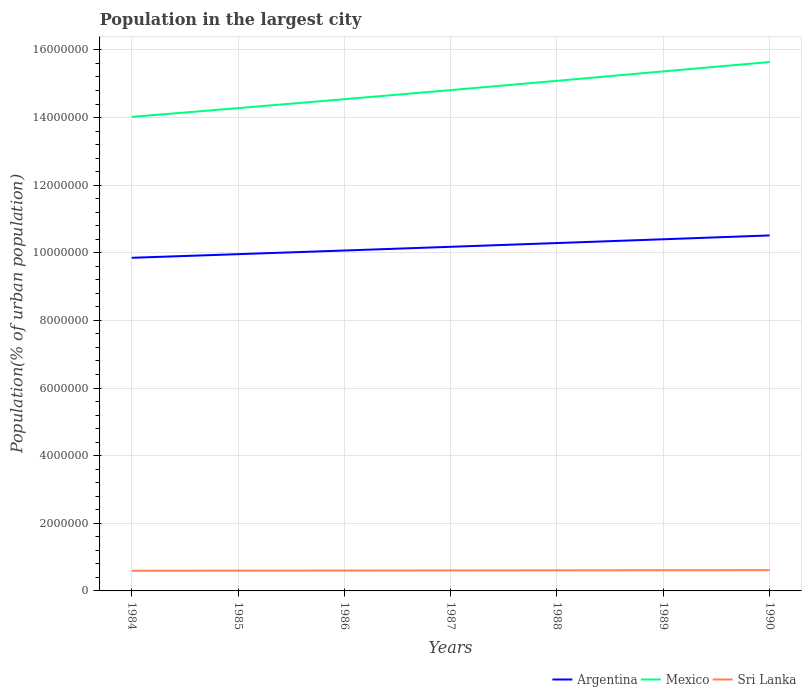Does the line corresponding to Sri Lanka intersect with the line corresponding to Mexico?
Offer a very short reply. No. Is the number of lines equal to the number of legend labels?
Make the answer very short. Yes. Across all years, what is the maximum population in the largest city in Argentina?
Your response must be concise. 9.85e+06. In which year was the population in the largest city in Mexico maximum?
Offer a very short reply. 1984. What is the total population in the largest city in Sri Lanka in the graph?
Keep it short and to the point. -1.15e+04. What is the difference between the highest and the second highest population in the largest city in Sri Lanka?
Keep it short and to the point. 1.72e+04. Does the graph contain grids?
Provide a short and direct response. Yes. Where does the legend appear in the graph?
Provide a short and direct response. Bottom right. How many legend labels are there?
Your answer should be very brief. 3. What is the title of the graph?
Make the answer very short. Population in the largest city. Does "Pakistan" appear as one of the legend labels in the graph?
Offer a terse response. No. What is the label or title of the Y-axis?
Make the answer very short. Population(% of urban population). What is the Population(% of urban population) of Argentina in 1984?
Your response must be concise. 9.85e+06. What is the Population(% of urban population) in Mexico in 1984?
Provide a succinct answer. 1.40e+07. What is the Population(% of urban population) in Sri Lanka in 1984?
Offer a terse response. 5.97e+05. What is the Population(% of urban population) in Argentina in 1985?
Keep it short and to the point. 9.96e+06. What is the Population(% of urban population) of Mexico in 1985?
Provide a short and direct response. 1.43e+07. What is the Population(% of urban population) in Sri Lanka in 1985?
Ensure brevity in your answer.  6.00e+05. What is the Population(% of urban population) in Argentina in 1986?
Your response must be concise. 1.01e+07. What is the Population(% of urban population) in Mexico in 1986?
Provide a short and direct response. 1.45e+07. What is the Population(% of urban population) in Sri Lanka in 1986?
Make the answer very short. 6.03e+05. What is the Population(% of urban population) of Argentina in 1987?
Provide a short and direct response. 1.02e+07. What is the Population(% of urban population) in Mexico in 1987?
Your answer should be compact. 1.48e+07. What is the Population(% of urban population) of Sri Lanka in 1987?
Provide a short and direct response. 6.05e+05. What is the Population(% of urban population) of Argentina in 1988?
Your answer should be compact. 1.03e+07. What is the Population(% of urban population) in Mexico in 1988?
Offer a terse response. 1.51e+07. What is the Population(% of urban population) of Sri Lanka in 1988?
Make the answer very short. 6.08e+05. What is the Population(% of urban population) of Argentina in 1989?
Make the answer very short. 1.04e+07. What is the Population(% of urban population) in Mexico in 1989?
Your response must be concise. 1.54e+07. What is the Population(% of urban population) in Sri Lanka in 1989?
Keep it short and to the point. 6.11e+05. What is the Population(% of urban population) of Argentina in 1990?
Your answer should be very brief. 1.05e+07. What is the Population(% of urban population) of Mexico in 1990?
Provide a short and direct response. 1.56e+07. What is the Population(% of urban population) of Sri Lanka in 1990?
Offer a terse response. 6.14e+05. Across all years, what is the maximum Population(% of urban population) in Argentina?
Ensure brevity in your answer.  1.05e+07. Across all years, what is the maximum Population(% of urban population) in Mexico?
Provide a succinct answer. 1.56e+07. Across all years, what is the maximum Population(% of urban population) in Sri Lanka?
Make the answer very short. 6.14e+05. Across all years, what is the minimum Population(% of urban population) in Argentina?
Give a very brief answer. 9.85e+06. Across all years, what is the minimum Population(% of urban population) of Mexico?
Your response must be concise. 1.40e+07. Across all years, what is the minimum Population(% of urban population) in Sri Lanka?
Your answer should be very brief. 5.97e+05. What is the total Population(% of urban population) of Argentina in the graph?
Give a very brief answer. 7.13e+07. What is the total Population(% of urban population) in Mexico in the graph?
Offer a very short reply. 1.04e+08. What is the total Population(% of urban population) of Sri Lanka in the graph?
Provide a succinct answer. 4.24e+06. What is the difference between the Population(% of urban population) in Argentina in 1984 and that in 1985?
Your answer should be compact. -1.07e+05. What is the difference between the Population(% of urban population) of Mexico in 1984 and that in 1985?
Ensure brevity in your answer.  -2.59e+05. What is the difference between the Population(% of urban population) of Sri Lanka in 1984 and that in 1985?
Make the answer very short. -2832. What is the difference between the Population(% of urban population) of Argentina in 1984 and that in 1986?
Provide a short and direct response. -2.16e+05. What is the difference between the Population(% of urban population) in Mexico in 1984 and that in 1986?
Your answer should be very brief. -5.23e+05. What is the difference between the Population(% of urban population) of Sri Lanka in 1984 and that in 1986?
Offer a very short reply. -5681. What is the difference between the Population(% of urban population) of Argentina in 1984 and that in 1987?
Provide a succinct answer. -3.25e+05. What is the difference between the Population(% of urban population) of Mexico in 1984 and that in 1987?
Offer a very short reply. -7.92e+05. What is the difference between the Population(% of urban population) of Sri Lanka in 1984 and that in 1987?
Offer a very short reply. -8544. What is the difference between the Population(% of urban population) in Argentina in 1984 and that in 1988?
Your answer should be compact. -4.36e+05. What is the difference between the Population(% of urban population) in Mexico in 1984 and that in 1988?
Make the answer very short. -1.07e+06. What is the difference between the Population(% of urban population) of Sri Lanka in 1984 and that in 1988?
Your answer should be very brief. -1.14e+04. What is the difference between the Population(% of urban population) in Argentina in 1984 and that in 1989?
Your answer should be compact. -5.48e+05. What is the difference between the Population(% of urban population) in Mexico in 1984 and that in 1989?
Your answer should be very brief. -1.35e+06. What is the difference between the Population(% of urban population) in Sri Lanka in 1984 and that in 1989?
Give a very brief answer. -1.43e+04. What is the difference between the Population(% of urban population) in Argentina in 1984 and that in 1990?
Offer a very short reply. -6.61e+05. What is the difference between the Population(% of urban population) of Mexico in 1984 and that in 1990?
Make the answer very short. -1.62e+06. What is the difference between the Population(% of urban population) of Sri Lanka in 1984 and that in 1990?
Provide a succinct answer. -1.72e+04. What is the difference between the Population(% of urban population) of Argentina in 1985 and that in 1986?
Your answer should be very brief. -1.08e+05. What is the difference between the Population(% of urban population) in Mexico in 1985 and that in 1986?
Make the answer very short. -2.64e+05. What is the difference between the Population(% of urban population) in Sri Lanka in 1985 and that in 1986?
Your answer should be very brief. -2849. What is the difference between the Population(% of urban population) in Argentina in 1985 and that in 1987?
Give a very brief answer. -2.18e+05. What is the difference between the Population(% of urban population) of Mexico in 1985 and that in 1987?
Keep it short and to the point. -5.33e+05. What is the difference between the Population(% of urban population) of Sri Lanka in 1985 and that in 1987?
Provide a short and direct response. -5712. What is the difference between the Population(% of urban population) of Argentina in 1985 and that in 1988?
Your response must be concise. -3.29e+05. What is the difference between the Population(% of urban population) of Mexico in 1985 and that in 1988?
Provide a succinct answer. -8.08e+05. What is the difference between the Population(% of urban population) in Sri Lanka in 1985 and that in 1988?
Give a very brief answer. -8592. What is the difference between the Population(% of urban population) of Argentina in 1985 and that in 1989?
Ensure brevity in your answer.  -4.41e+05. What is the difference between the Population(% of urban population) of Mexico in 1985 and that in 1989?
Make the answer very short. -1.09e+06. What is the difference between the Population(% of urban population) in Sri Lanka in 1985 and that in 1989?
Keep it short and to the point. -1.15e+04. What is the difference between the Population(% of urban population) in Argentina in 1985 and that in 1990?
Make the answer very short. -5.54e+05. What is the difference between the Population(% of urban population) in Mexico in 1985 and that in 1990?
Make the answer very short. -1.36e+06. What is the difference between the Population(% of urban population) of Sri Lanka in 1985 and that in 1990?
Give a very brief answer. -1.44e+04. What is the difference between the Population(% of urban population) in Argentina in 1986 and that in 1987?
Ensure brevity in your answer.  -1.10e+05. What is the difference between the Population(% of urban population) in Mexico in 1986 and that in 1987?
Provide a succinct answer. -2.69e+05. What is the difference between the Population(% of urban population) in Sri Lanka in 1986 and that in 1987?
Your response must be concise. -2863. What is the difference between the Population(% of urban population) in Argentina in 1986 and that in 1988?
Your answer should be compact. -2.21e+05. What is the difference between the Population(% of urban population) of Mexico in 1986 and that in 1988?
Ensure brevity in your answer.  -5.44e+05. What is the difference between the Population(% of urban population) of Sri Lanka in 1986 and that in 1988?
Offer a terse response. -5743. What is the difference between the Population(% of urban population) of Argentina in 1986 and that in 1989?
Your response must be concise. -3.32e+05. What is the difference between the Population(% of urban population) of Mexico in 1986 and that in 1989?
Keep it short and to the point. -8.22e+05. What is the difference between the Population(% of urban population) in Sri Lanka in 1986 and that in 1989?
Your response must be concise. -8629. What is the difference between the Population(% of urban population) in Argentina in 1986 and that in 1990?
Offer a terse response. -4.46e+05. What is the difference between the Population(% of urban population) of Mexico in 1986 and that in 1990?
Offer a very short reply. -1.10e+06. What is the difference between the Population(% of urban population) of Sri Lanka in 1986 and that in 1990?
Your response must be concise. -1.15e+04. What is the difference between the Population(% of urban population) in Argentina in 1987 and that in 1988?
Offer a very short reply. -1.11e+05. What is the difference between the Population(% of urban population) of Mexico in 1987 and that in 1988?
Provide a succinct answer. -2.74e+05. What is the difference between the Population(% of urban population) in Sri Lanka in 1987 and that in 1988?
Your answer should be compact. -2880. What is the difference between the Population(% of urban population) of Argentina in 1987 and that in 1989?
Your answer should be compact. -2.23e+05. What is the difference between the Population(% of urban population) of Mexico in 1987 and that in 1989?
Give a very brief answer. -5.53e+05. What is the difference between the Population(% of urban population) in Sri Lanka in 1987 and that in 1989?
Provide a short and direct response. -5766. What is the difference between the Population(% of urban population) in Argentina in 1987 and that in 1990?
Give a very brief answer. -3.36e+05. What is the difference between the Population(% of urban population) in Mexico in 1987 and that in 1990?
Provide a succinct answer. -8.31e+05. What is the difference between the Population(% of urban population) of Sri Lanka in 1987 and that in 1990?
Make the answer very short. -8669. What is the difference between the Population(% of urban population) of Argentina in 1988 and that in 1989?
Keep it short and to the point. -1.12e+05. What is the difference between the Population(% of urban population) in Mexico in 1988 and that in 1989?
Keep it short and to the point. -2.79e+05. What is the difference between the Population(% of urban population) of Sri Lanka in 1988 and that in 1989?
Your answer should be compact. -2886. What is the difference between the Population(% of urban population) in Argentina in 1988 and that in 1990?
Your response must be concise. -2.25e+05. What is the difference between the Population(% of urban population) in Mexico in 1988 and that in 1990?
Give a very brief answer. -5.56e+05. What is the difference between the Population(% of urban population) of Sri Lanka in 1988 and that in 1990?
Your response must be concise. -5789. What is the difference between the Population(% of urban population) in Argentina in 1989 and that in 1990?
Your answer should be very brief. -1.13e+05. What is the difference between the Population(% of urban population) in Mexico in 1989 and that in 1990?
Make the answer very short. -2.77e+05. What is the difference between the Population(% of urban population) in Sri Lanka in 1989 and that in 1990?
Provide a short and direct response. -2903. What is the difference between the Population(% of urban population) in Argentina in 1984 and the Population(% of urban population) in Mexico in 1985?
Your answer should be compact. -4.43e+06. What is the difference between the Population(% of urban population) in Argentina in 1984 and the Population(% of urban population) in Sri Lanka in 1985?
Your response must be concise. 9.25e+06. What is the difference between the Population(% of urban population) of Mexico in 1984 and the Population(% of urban population) of Sri Lanka in 1985?
Your answer should be compact. 1.34e+07. What is the difference between the Population(% of urban population) of Argentina in 1984 and the Population(% of urban population) of Mexico in 1986?
Offer a very short reply. -4.69e+06. What is the difference between the Population(% of urban population) in Argentina in 1984 and the Population(% of urban population) in Sri Lanka in 1986?
Provide a short and direct response. 9.25e+06. What is the difference between the Population(% of urban population) of Mexico in 1984 and the Population(% of urban population) of Sri Lanka in 1986?
Offer a very short reply. 1.34e+07. What is the difference between the Population(% of urban population) of Argentina in 1984 and the Population(% of urban population) of Mexico in 1987?
Offer a very short reply. -4.96e+06. What is the difference between the Population(% of urban population) of Argentina in 1984 and the Population(% of urban population) of Sri Lanka in 1987?
Provide a short and direct response. 9.25e+06. What is the difference between the Population(% of urban population) of Mexico in 1984 and the Population(% of urban population) of Sri Lanka in 1987?
Provide a short and direct response. 1.34e+07. What is the difference between the Population(% of urban population) in Argentina in 1984 and the Population(% of urban population) in Mexico in 1988?
Your response must be concise. -5.23e+06. What is the difference between the Population(% of urban population) of Argentina in 1984 and the Population(% of urban population) of Sri Lanka in 1988?
Make the answer very short. 9.24e+06. What is the difference between the Population(% of urban population) of Mexico in 1984 and the Population(% of urban population) of Sri Lanka in 1988?
Your response must be concise. 1.34e+07. What is the difference between the Population(% of urban population) of Argentina in 1984 and the Population(% of urban population) of Mexico in 1989?
Your answer should be compact. -5.51e+06. What is the difference between the Population(% of urban population) of Argentina in 1984 and the Population(% of urban population) of Sri Lanka in 1989?
Give a very brief answer. 9.24e+06. What is the difference between the Population(% of urban population) of Mexico in 1984 and the Population(% of urban population) of Sri Lanka in 1989?
Keep it short and to the point. 1.34e+07. What is the difference between the Population(% of urban population) in Argentina in 1984 and the Population(% of urban population) in Mexico in 1990?
Your answer should be very brief. -5.79e+06. What is the difference between the Population(% of urban population) in Argentina in 1984 and the Population(% of urban population) in Sri Lanka in 1990?
Provide a short and direct response. 9.24e+06. What is the difference between the Population(% of urban population) of Mexico in 1984 and the Population(% of urban population) of Sri Lanka in 1990?
Make the answer very short. 1.34e+07. What is the difference between the Population(% of urban population) in Argentina in 1985 and the Population(% of urban population) in Mexico in 1986?
Offer a terse response. -4.58e+06. What is the difference between the Population(% of urban population) in Argentina in 1985 and the Population(% of urban population) in Sri Lanka in 1986?
Your answer should be very brief. 9.36e+06. What is the difference between the Population(% of urban population) of Mexico in 1985 and the Population(% of urban population) of Sri Lanka in 1986?
Your response must be concise. 1.37e+07. What is the difference between the Population(% of urban population) of Argentina in 1985 and the Population(% of urban population) of Mexico in 1987?
Offer a terse response. -4.85e+06. What is the difference between the Population(% of urban population) of Argentina in 1985 and the Population(% of urban population) of Sri Lanka in 1987?
Your response must be concise. 9.35e+06. What is the difference between the Population(% of urban population) in Mexico in 1985 and the Population(% of urban population) in Sri Lanka in 1987?
Your response must be concise. 1.37e+07. What is the difference between the Population(% of urban population) of Argentina in 1985 and the Population(% of urban population) of Mexico in 1988?
Give a very brief answer. -5.13e+06. What is the difference between the Population(% of urban population) of Argentina in 1985 and the Population(% of urban population) of Sri Lanka in 1988?
Make the answer very short. 9.35e+06. What is the difference between the Population(% of urban population) in Mexico in 1985 and the Population(% of urban population) in Sri Lanka in 1988?
Offer a very short reply. 1.37e+07. What is the difference between the Population(% of urban population) in Argentina in 1985 and the Population(% of urban population) in Mexico in 1989?
Ensure brevity in your answer.  -5.41e+06. What is the difference between the Population(% of urban population) in Argentina in 1985 and the Population(% of urban population) in Sri Lanka in 1989?
Keep it short and to the point. 9.35e+06. What is the difference between the Population(% of urban population) in Mexico in 1985 and the Population(% of urban population) in Sri Lanka in 1989?
Your response must be concise. 1.37e+07. What is the difference between the Population(% of urban population) of Argentina in 1985 and the Population(% of urban population) of Mexico in 1990?
Give a very brief answer. -5.68e+06. What is the difference between the Population(% of urban population) in Argentina in 1985 and the Population(% of urban population) in Sri Lanka in 1990?
Your answer should be compact. 9.35e+06. What is the difference between the Population(% of urban population) in Mexico in 1985 and the Population(% of urban population) in Sri Lanka in 1990?
Offer a terse response. 1.37e+07. What is the difference between the Population(% of urban population) in Argentina in 1986 and the Population(% of urban population) in Mexico in 1987?
Your response must be concise. -4.74e+06. What is the difference between the Population(% of urban population) of Argentina in 1986 and the Population(% of urban population) of Sri Lanka in 1987?
Keep it short and to the point. 9.46e+06. What is the difference between the Population(% of urban population) in Mexico in 1986 and the Population(% of urban population) in Sri Lanka in 1987?
Your response must be concise. 1.39e+07. What is the difference between the Population(% of urban population) in Argentina in 1986 and the Population(% of urban population) in Mexico in 1988?
Provide a succinct answer. -5.02e+06. What is the difference between the Population(% of urban population) in Argentina in 1986 and the Population(% of urban population) in Sri Lanka in 1988?
Your response must be concise. 9.46e+06. What is the difference between the Population(% of urban population) of Mexico in 1986 and the Population(% of urban population) of Sri Lanka in 1988?
Make the answer very short. 1.39e+07. What is the difference between the Population(% of urban population) in Argentina in 1986 and the Population(% of urban population) in Mexico in 1989?
Ensure brevity in your answer.  -5.30e+06. What is the difference between the Population(% of urban population) in Argentina in 1986 and the Population(% of urban population) in Sri Lanka in 1989?
Your response must be concise. 9.46e+06. What is the difference between the Population(% of urban population) in Mexico in 1986 and the Population(% of urban population) in Sri Lanka in 1989?
Your answer should be very brief. 1.39e+07. What is the difference between the Population(% of urban population) of Argentina in 1986 and the Population(% of urban population) of Mexico in 1990?
Offer a very short reply. -5.57e+06. What is the difference between the Population(% of urban population) in Argentina in 1986 and the Population(% of urban population) in Sri Lanka in 1990?
Offer a terse response. 9.45e+06. What is the difference between the Population(% of urban population) in Mexico in 1986 and the Population(% of urban population) in Sri Lanka in 1990?
Your answer should be compact. 1.39e+07. What is the difference between the Population(% of urban population) of Argentina in 1987 and the Population(% of urban population) of Mexico in 1988?
Give a very brief answer. -4.91e+06. What is the difference between the Population(% of urban population) of Argentina in 1987 and the Population(% of urban population) of Sri Lanka in 1988?
Offer a terse response. 9.57e+06. What is the difference between the Population(% of urban population) of Mexico in 1987 and the Population(% of urban population) of Sri Lanka in 1988?
Give a very brief answer. 1.42e+07. What is the difference between the Population(% of urban population) in Argentina in 1987 and the Population(% of urban population) in Mexico in 1989?
Your response must be concise. -5.19e+06. What is the difference between the Population(% of urban population) in Argentina in 1987 and the Population(% of urban population) in Sri Lanka in 1989?
Keep it short and to the point. 9.57e+06. What is the difference between the Population(% of urban population) of Mexico in 1987 and the Population(% of urban population) of Sri Lanka in 1989?
Your answer should be very brief. 1.42e+07. What is the difference between the Population(% of urban population) in Argentina in 1987 and the Population(% of urban population) in Mexico in 1990?
Offer a very short reply. -5.47e+06. What is the difference between the Population(% of urban population) of Argentina in 1987 and the Population(% of urban population) of Sri Lanka in 1990?
Offer a very short reply. 9.56e+06. What is the difference between the Population(% of urban population) in Mexico in 1987 and the Population(% of urban population) in Sri Lanka in 1990?
Make the answer very short. 1.42e+07. What is the difference between the Population(% of urban population) in Argentina in 1988 and the Population(% of urban population) in Mexico in 1989?
Keep it short and to the point. -5.08e+06. What is the difference between the Population(% of urban population) of Argentina in 1988 and the Population(% of urban population) of Sri Lanka in 1989?
Make the answer very short. 9.68e+06. What is the difference between the Population(% of urban population) in Mexico in 1988 and the Population(% of urban population) in Sri Lanka in 1989?
Make the answer very short. 1.45e+07. What is the difference between the Population(% of urban population) in Argentina in 1988 and the Population(% of urban population) in Mexico in 1990?
Offer a very short reply. -5.35e+06. What is the difference between the Population(% of urban population) of Argentina in 1988 and the Population(% of urban population) of Sri Lanka in 1990?
Provide a short and direct response. 9.67e+06. What is the difference between the Population(% of urban population) of Mexico in 1988 and the Population(% of urban population) of Sri Lanka in 1990?
Ensure brevity in your answer.  1.45e+07. What is the difference between the Population(% of urban population) in Argentina in 1989 and the Population(% of urban population) in Mexico in 1990?
Provide a short and direct response. -5.24e+06. What is the difference between the Population(% of urban population) of Argentina in 1989 and the Population(% of urban population) of Sri Lanka in 1990?
Your response must be concise. 9.79e+06. What is the difference between the Population(% of urban population) in Mexico in 1989 and the Population(% of urban population) in Sri Lanka in 1990?
Make the answer very short. 1.48e+07. What is the average Population(% of urban population) of Argentina per year?
Ensure brevity in your answer.  1.02e+07. What is the average Population(% of urban population) of Mexico per year?
Give a very brief answer. 1.48e+07. What is the average Population(% of urban population) in Sri Lanka per year?
Give a very brief answer. 6.05e+05. In the year 1984, what is the difference between the Population(% of urban population) of Argentina and Population(% of urban population) of Mexico?
Make the answer very short. -4.17e+06. In the year 1984, what is the difference between the Population(% of urban population) of Argentina and Population(% of urban population) of Sri Lanka?
Make the answer very short. 9.26e+06. In the year 1984, what is the difference between the Population(% of urban population) in Mexico and Population(% of urban population) in Sri Lanka?
Offer a very short reply. 1.34e+07. In the year 1985, what is the difference between the Population(% of urban population) of Argentina and Population(% of urban population) of Mexico?
Offer a very short reply. -4.32e+06. In the year 1985, what is the difference between the Population(% of urban population) in Argentina and Population(% of urban population) in Sri Lanka?
Ensure brevity in your answer.  9.36e+06. In the year 1985, what is the difference between the Population(% of urban population) of Mexico and Population(% of urban population) of Sri Lanka?
Keep it short and to the point. 1.37e+07. In the year 1986, what is the difference between the Population(% of urban population) in Argentina and Population(% of urban population) in Mexico?
Offer a terse response. -4.47e+06. In the year 1986, what is the difference between the Population(% of urban population) of Argentina and Population(% of urban population) of Sri Lanka?
Your answer should be very brief. 9.46e+06. In the year 1986, what is the difference between the Population(% of urban population) in Mexico and Population(% of urban population) in Sri Lanka?
Ensure brevity in your answer.  1.39e+07. In the year 1987, what is the difference between the Population(% of urban population) in Argentina and Population(% of urban population) in Mexico?
Your answer should be compact. -4.63e+06. In the year 1987, what is the difference between the Population(% of urban population) in Argentina and Population(% of urban population) in Sri Lanka?
Offer a terse response. 9.57e+06. In the year 1987, what is the difference between the Population(% of urban population) in Mexico and Population(% of urban population) in Sri Lanka?
Make the answer very short. 1.42e+07. In the year 1988, what is the difference between the Population(% of urban population) in Argentina and Population(% of urban population) in Mexico?
Keep it short and to the point. -4.80e+06. In the year 1988, what is the difference between the Population(% of urban population) of Argentina and Population(% of urban population) of Sri Lanka?
Provide a short and direct response. 9.68e+06. In the year 1988, what is the difference between the Population(% of urban population) in Mexico and Population(% of urban population) in Sri Lanka?
Your response must be concise. 1.45e+07. In the year 1989, what is the difference between the Population(% of urban population) in Argentina and Population(% of urban population) in Mexico?
Keep it short and to the point. -4.96e+06. In the year 1989, what is the difference between the Population(% of urban population) of Argentina and Population(% of urban population) of Sri Lanka?
Offer a terse response. 9.79e+06. In the year 1989, what is the difference between the Population(% of urban population) of Mexico and Population(% of urban population) of Sri Lanka?
Offer a terse response. 1.48e+07. In the year 1990, what is the difference between the Population(% of urban population) in Argentina and Population(% of urban population) in Mexico?
Offer a terse response. -5.13e+06. In the year 1990, what is the difference between the Population(% of urban population) in Argentina and Population(% of urban population) in Sri Lanka?
Make the answer very short. 9.90e+06. In the year 1990, what is the difference between the Population(% of urban population) of Mexico and Population(% of urban population) of Sri Lanka?
Provide a succinct answer. 1.50e+07. What is the ratio of the Population(% of urban population) in Mexico in 1984 to that in 1985?
Provide a short and direct response. 0.98. What is the ratio of the Population(% of urban population) in Argentina in 1984 to that in 1986?
Offer a terse response. 0.98. What is the ratio of the Population(% of urban population) in Sri Lanka in 1984 to that in 1986?
Keep it short and to the point. 0.99. What is the ratio of the Population(% of urban population) of Mexico in 1984 to that in 1987?
Your answer should be compact. 0.95. What is the ratio of the Population(% of urban population) in Sri Lanka in 1984 to that in 1987?
Your answer should be very brief. 0.99. What is the ratio of the Population(% of urban population) in Argentina in 1984 to that in 1988?
Your response must be concise. 0.96. What is the ratio of the Population(% of urban population) in Mexico in 1984 to that in 1988?
Keep it short and to the point. 0.93. What is the ratio of the Population(% of urban population) in Sri Lanka in 1984 to that in 1988?
Ensure brevity in your answer.  0.98. What is the ratio of the Population(% of urban population) in Argentina in 1984 to that in 1989?
Your answer should be very brief. 0.95. What is the ratio of the Population(% of urban population) of Mexico in 1984 to that in 1989?
Offer a very short reply. 0.91. What is the ratio of the Population(% of urban population) in Sri Lanka in 1984 to that in 1989?
Provide a short and direct response. 0.98. What is the ratio of the Population(% of urban population) in Argentina in 1984 to that in 1990?
Ensure brevity in your answer.  0.94. What is the ratio of the Population(% of urban population) of Mexico in 1984 to that in 1990?
Ensure brevity in your answer.  0.9. What is the ratio of the Population(% of urban population) of Argentina in 1985 to that in 1986?
Give a very brief answer. 0.99. What is the ratio of the Population(% of urban population) in Mexico in 1985 to that in 1986?
Your response must be concise. 0.98. What is the ratio of the Population(% of urban population) in Sri Lanka in 1985 to that in 1986?
Keep it short and to the point. 1. What is the ratio of the Population(% of urban population) in Argentina in 1985 to that in 1987?
Offer a very short reply. 0.98. What is the ratio of the Population(% of urban population) of Sri Lanka in 1985 to that in 1987?
Your answer should be very brief. 0.99. What is the ratio of the Population(% of urban population) of Argentina in 1985 to that in 1988?
Your answer should be very brief. 0.97. What is the ratio of the Population(% of urban population) in Mexico in 1985 to that in 1988?
Offer a terse response. 0.95. What is the ratio of the Population(% of urban population) in Sri Lanka in 1985 to that in 1988?
Your answer should be compact. 0.99. What is the ratio of the Population(% of urban population) of Argentina in 1985 to that in 1989?
Give a very brief answer. 0.96. What is the ratio of the Population(% of urban population) of Mexico in 1985 to that in 1989?
Offer a very short reply. 0.93. What is the ratio of the Population(% of urban population) in Sri Lanka in 1985 to that in 1989?
Keep it short and to the point. 0.98. What is the ratio of the Population(% of urban population) in Argentina in 1985 to that in 1990?
Offer a terse response. 0.95. What is the ratio of the Population(% of urban population) in Mexico in 1985 to that in 1990?
Provide a succinct answer. 0.91. What is the ratio of the Population(% of urban population) in Sri Lanka in 1985 to that in 1990?
Offer a terse response. 0.98. What is the ratio of the Population(% of urban population) of Argentina in 1986 to that in 1987?
Offer a terse response. 0.99. What is the ratio of the Population(% of urban population) of Mexico in 1986 to that in 1987?
Provide a short and direct response. 0.98. What is the ratio of the Population(% of urban population) in Sri Lanka in 1986 to that in 1987?
Your response must be concise. 1. What is the ratio of the Population(% of urban population) in Argentina in 1986 to that in 1988?
Your response must be concise. 0.98. What is the ratio of the Population(% of urban population) of Sri Lanka in 1986 to that in 1988?
Your answer should be very brief. 0.99. What is the ratio of the Population(% of urban population) of Argentina in 1986 to that in 1989?
Give a very brief answer. 0.97. What is the ratio of the Population(% of urban population) of Mexico in 1986 to that in 1989?
Keep it short and to the point. 0.95. What is the ratio of the Population(% of urban population) of Sri Lanka in 1986 to that in 1989?
Your response must be concise. 0.99. What is the ratio of the Population(% of urban population) of Argentina in 1986 to that in 1990?
Give a very brief answer. 0.96. What is the ratio of the Population(% of urban population) in Mexico in 1986 to that in 1990?
Offer a terse response. 0.93. What is the ratio of the Population(% of urban population) of Sri Lanka in 1986 to that in 1990?
Give a very brief answer. 0.98. What is the ratio of the Population(% of urban population) in Argentina in 1987 to that in 1988?
Ensure brevity in your answer.  0.99. What is the ratio of the Population(% of urban population) in Mexico in 1987 to that in 1988?
Your answer should be very brief. 0.98. What is the ratio of the Population(% of urban population) of Argentina in 1987 to that in 1989?
Provide a succinct answer. 0.98. What is the ratio of the Population(% of urban population) in Mexico in 1987 to that in 1989?
Provide a short and direct response. 0.96. What is the ratio of the Population(% of urban population) in Sri Lanka in 1987 to that in 1989?
Provide a short and direct response. 0.99. What is the ratio of the Population(% of urban population) of Mexico in 1987 to that in 1990?
Provide a succinct answer. 0.95. What is the ratio of the Population(% of urban population) in Sri Lanka in 1987 to that in 1990?
Your response must be concise. 0.99. What is the ratio of the Population(% of urban population) of Mexico in 1988 to that in 1989?
Your response must be concise. 0.98. What is the ratio of the Population(% of urban population) of Argentina in 1988 to that in 1990?
Offer a terse response. 0.98. What is the ratio of the Population(% of urban population) of Mexico in 1988 to that in 1990?
Ensure brevity in your answer.  0.96. What is the ratio of the Population(% of urban population) of Sri Lanka in 1988 to that in 1990?
Give a very brief answer. 0.99. What is the ratio of the Population(% of urban population) in Mexico in 1989 to that in 1990?
Offer a very short reply. 0.98. What is the ratio of the Population(% of urban population) of Sri Lanka in 1989 to that in 1990?
Your response must be concise. 1. What is the difference between the highest and the second highest Population(% of urban population) in Argentina?
Your response must be concise. 1.13e+05. What is the difference between the highest and the second highest Population(% of urban population) of Mexico?
Your response must be concise. 2.77e+05. What is the difference between the highest and the second highest Population(% of urban population) of Sri Lanka?
Your answer should be compact. 2903. What is the difference between the highest and the lowest Population(% of urban population) in Argentina?
Provide a succinct answer. 6.61e+05. What is the difference between the highest and the lowest Population(% of urban population) in Mexico?
Make the answer very short. 1.62e+06. What is the difference between the highest and the lowest Population(% of urban population) of Sri Lanka?
Offer a terse response. 1.72e+04. 